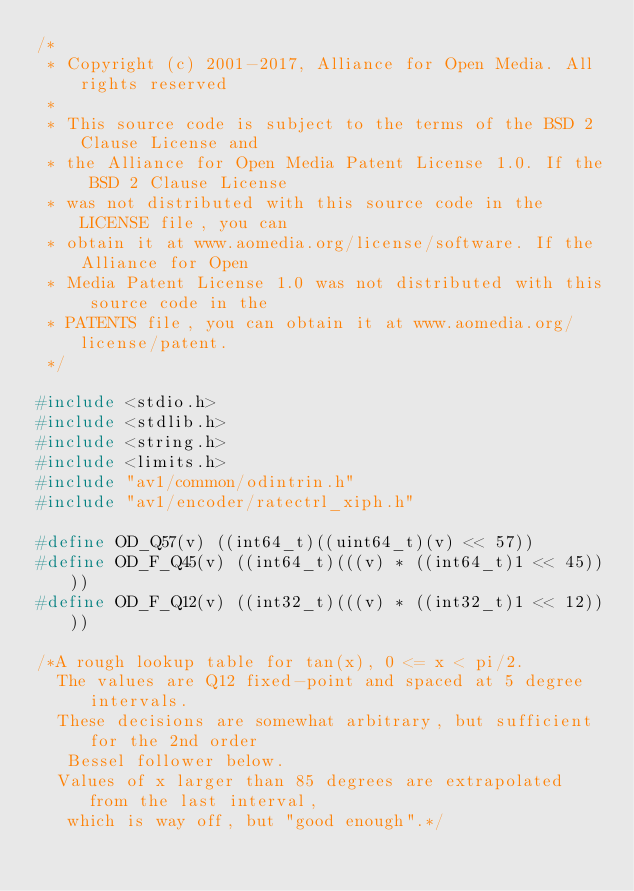Convert code to text. <code><loc_0><loc_0><loc_500><loc_500><_C_>/*
 * Copyright (c) 2001-2017, Alliance for Open Media. All rights reserved
 *
 * This source code is subject to the terms of the BSD 2 Clause License and
 * the Alliance for Open Media Patent License 1.0. If the BSD 2 Clause License
 * was not distributed with this source code in the LICENSE file, you can
 * obtain it at www.aomedia.org/license/software. If the Alliance for Open
 * Media Patent License 1.0 was not distributed with this source code in the
 * PATENTS file, you can obtain it at www.aomedia.org/license/patent.
 */

#include <stdio.h>
#include <stdlib.h>
#include <string.h>
#include <limits.h>
#include "av1/common/odintrin.h"
#include "av1/encoder/ratectrl_xiph.h"

#define OD_Q57(v) ((int64_t)((uint64_t)(v) << 57))
#define OD_F_Q45(v) ((int64_t)(((v) * ((int64_t)1 << 45))))
#define OD_F_Q12(v) ((int32_t)(((v) * ((int32_t)1 << 12))))

/*A rough lookup table for tan(x), 0 <= x < pi/2.
  The values are Q12 fixed-point and spaced at 5 degree intervals.
  These decisions are somewhat arbitrary, but sufficient for the 2nd order
   Bessel follower below.
  Values of x larger than 85 degrees are extrapolated from the last interval,
   which is way off, but "good enough".*/</code> 